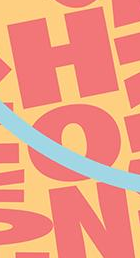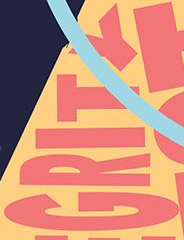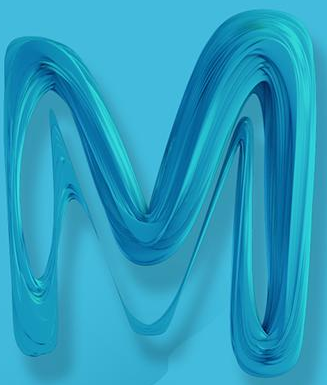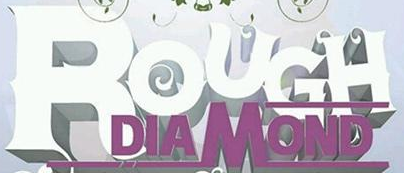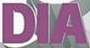What text is displayed in these images sequentially, separated by a semicolon? HON; GRITY; M; ROUGH; DIA 